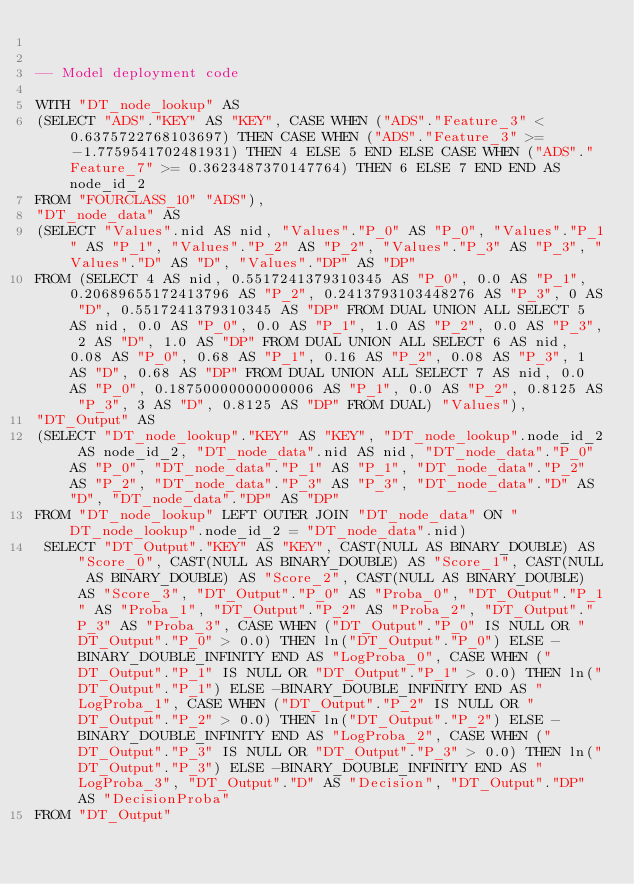<code> <loc_0><loc_0><loc_500><loc_500><_SQL_>

-- Model deployment code

WITH "DT_node_lookup" AS 
(SELECT "ADS"."KEY" AS "KEY", CASE WHEN ("ADS"."Feature_3" < 0.6375722768103697) THEN CASE WHEN ("ADS"."Feature_3" >= -1.7759541702481931) THEN 4 ELSE 5 END ELSE CASE WHEN ("ADS"."Feature_7" >= 0.3623487370147764) THEN 6 ELSE 7 END END AS node_id_2 
FROM "FOURCLASS_10" "ADS"), 
"DT_node_data" AS 
(SELECT "Values".nid AS nid, "Values"."P_0" AS "P_0", "Values"."P_1" AS "P_1", "Values"."P_2" AS "P_2", "Values"."P_3" AS "P_3", "Values"."D" AS "D", "Values"."DP" AS "DP" 
FROM (SELECT 4 AS nid, 0.5517241379310345 AS "P_0", 0.0 AS "P_1", 0.20689655172413796 AS "P_2", 0.2413793103448276 AS "P_3", 0 AS "D", 0.5517241379310345 AS "DP" FROM DUAL UNION ALL SELECT 5 AS nid, 0.0 AS "P_0", 0.0 AS "P_1", 1.0 AS "P_2", 0.0 AS "P_3", 2 AS "D", 1.0 AS "DP" FROM DUAL UNION ALL SELECT 6 AS nid, 0.08 AS "P_0", 0.68 AS "P_1", 0.16 AS "P_2", 0.08 AS "P_3", 1 AS "D", 0.68 AS "DP" FROM DUAL UNION ALL SELECT 7 AS nid, 0.0 AS "P_0", 0.18750000000000006 AS "P_1", 0.0 AS "P_2", 0.8125 AS "P_3", 3 AS "D", 0.8125 AS "DP" FROM DUAL) "Values"), 
"DT_Output" AS 
(SELECT "DT_node_lookup"."KEY" AS "KEY", "DT_node_lookup".node_id_2 AS node_id_2, "DT_node_data".nid AS nid, "DT_node_data"."P_0" AS "P_0", "DT_node_data"."P_1" AS "P_1", "DT_node_data"."P_2" AS "P_2", "DT_node_data"."P_3" AS "P_3", "DT_node_data"."D" AS "D", "DT_node_data"."DP" AS "DP" 
FROM "DT_node_lookup" LEFT OUTER JOIN "DT_node_data" ON "DT_node_lookup".node_id_2 = "DT_node_data".nid)
 SELECT "DT_Output"."KEY" AS "KEY", CAST(NULL AS BINARY_DOUBLE) AS "Score_0", CAST(NULL AS BINARY_DOUBLE) AS "Score_1", CAST(NULL AS BINARY_DOUBLE) AS "Score_2", CAST(NULL AS BINARY_DOUBLE) AS "Score_3", "DT_Output"."P_0" AS "Proba_0", "DT_Output"."P_1" AS "Proba_1", "DT_Output"."P_2" AS "Proba_2", "DT_Output"."P_3" AS "Proba_3", CASE WHEN ("DT_Output"."P_0" IS NULL OR "DT_Output"."P_0" > 0.0) THEN ln("DT_Output"."P_0") ELSE -BINARY_DOUBLE_INFINITY END AS "LogProba_0", CASE WHEN ("DT_Output"."P_1" IS NULL OR "DT_Output"."P_1" > 0.0) THEN ln("DT_Output"."P_1") ELSE -BINARY_DOUBLE_INFINITY END AS "LogProba_1", CASE WHEN ("DT_Output"."P_2" IS NULL OR "DT_Output"."P_2" > 0.0) THEN ln("DT_Output"."P_2") ELSE -BINARY_DOUBLE_INFINITY END AS "LogProba_2", CASE WHEN ("DT_Output"."P_3" IS NULL OR "DT_Output"."P_3" > 0.0) THEN ln("DT_Output"."P_3") ELSE -BINARY_DOUBLE_INFINITY END AS "LogProba_3", "DT_Output"."D" AS "Decision", "DT_Output"."DP" AS "DecisionProba" 
FROM "DT_Output"</code> 